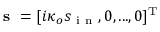Convert formula to latex. <formula><loc_0><loc_0><loc_500><loc_500>s = [ i \kappa _ { o } s _ { i n } , 0 , \dots , 0 ] ^ { T }</formula> 